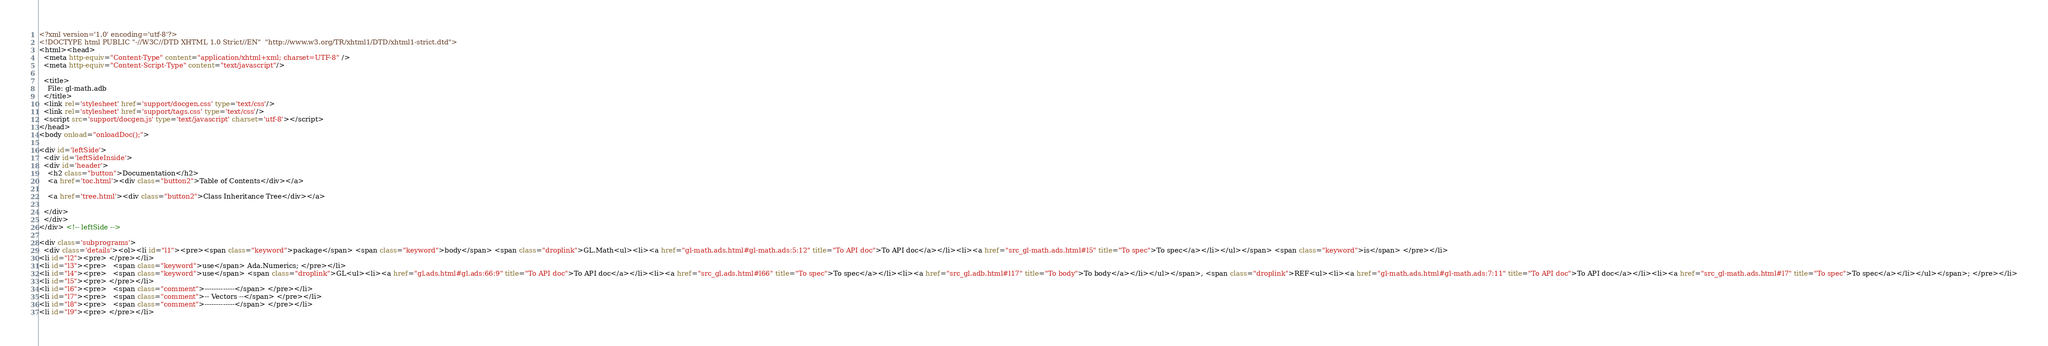<code> <loc_0><loc_0><loc_500><loc_500><_HTML_><?xml version='1.0' encoding='utf-8'?>
<!DOCTYPE html PUBLIC "-//W3C//DTD XHTML 1.0 Strict//EN"  "http://www.w3.org/TR/xhtml1/DTD/xhtml1-strict.dtd">
<html><head>
  <meta http-equiv="Content-Type" content="application/xhtml+xml; charset=UTF-8" />
  <meta http-equiv="Content-Script-Type" content="text/javascript"/>

  <title>
    File: gl-math.adb
  </title>
  <link rel='stylesheet' href='support/docgen.css' type='text/css'/>
  <link rel='stylesheet' href='support/tags.css' type='text/css'/>
  <script src='support/docgen.js' type='text/javascript' charset='utf-8'></script>
</head>
<body onload="onloadDoc();">

<div id='leftSide'>
  <div id='leftSideInside'>
  <div id='header'>
    <h2 class="button">Documentation</h2>
    <a href='toc.html'><div class="button2">Table of Contents</div></a>

    <a href='tree.html'><div class="button2">Class Inheritance Tree</div></a>

  </div>
  </div>
</div> <!-- leftSide -->

<div class='subprograms'>
  <div class='details'><ol><li id="l1"><pre><span class="keyword">package</span> <span class="keyword">body</span> <span class="droplink">GL.Math<ul><li><a href="gl-math.ads.html#gl-math.ads:5:12" title="To API doc">To API doc</a></li><li><a href="src_gl-math.ads.html#l5" title="To spec">To spec</a></li></ul></span> <span class="keyword">is</span> </pre></li>
<li id="l2"><pre> </pre></li>
<li id="l3"><pre>   <span class="keyword">use</span> Ada.Numerics; </pre></li>
<li id="l4"><pre>   <span class="keyword">use</span> <span class="droplink">GL<ul><li><a href="gl.ads.html#gl.ads:66:9" title="To API doc">To API doc</a></li><li><a href="src_gl.ads.html#l66" title="To spec">To spec</a></li><li><a href="src_gl.adb.html#l17" title="To body">To body</a></li></ul></span>, <span class="droplink">REF<ul><li><a href="gl-math.ads.html#gl-math.ads:7:11" title="To API doc">To API doc</a></li><li><a href="src_gl-math.ads.html#l7" title="To spec">To spec</a></li></ul></span>; </pre></li>
<li id="l5"><pre> </pre></li>
<li id="l6"><pre>   <span class="comment">-------------</span> </pre></li>
<li id="l7"><pre>   <span class="comment">-- Vectors --</span> </pre></li>
<li id="l8"><pre>   <span class="comment">-------------</span> </pre></li>
<li id="l9"><pre> </pre></li></code> 